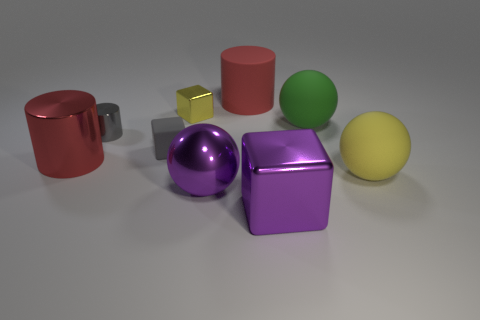How many objects are matte things in front of the big red metal thing or tiny gray matte cylinders?
Make the answer very short. 1. Is the red metallic cylinder the same size as the matte cube?
Offer a terse response. No. There is a large object that is left of the purple ball; what color is it?
Make the answer very short. Red. What size is the gray object that is made of the same material as the tiny yellow block?
Your answer should be very brief. Small. Is the size of the gray matte cube the same as the shiny block on the left side of the red rubber cylinder?
Your response must be concise. Yes. There is a yellow thing that is to the left of the large purple ball; what is its material?
Your answer should be very brief. Metal. How many rubber objects are in front of the shiny cube on the left side of the big metal ball?
Provide a short and direct response. 3. Is there another big rubber thing of the same shape as the large red matte object?
Ensure brevity in your answer.  No. Is the size of the ball behind the yellow ball the same as the object that is in front of the big purple shiny sphere?
Provide a short and direct response. Yes. The purple thing behind the large block on the right side of the tiny gray metallic cylinder is what shape?
Offer a terse response. Sphere. 